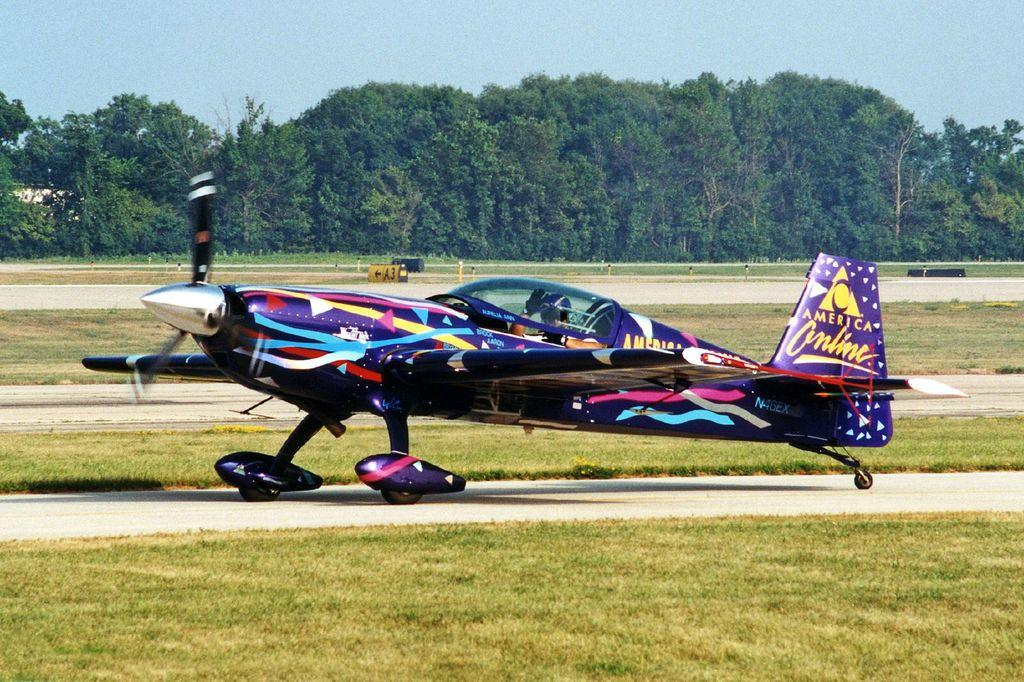<image>
Write a terse but informative summary of the picture. A wildly painted airplane with the words America Online on the tail sits on the runway. 